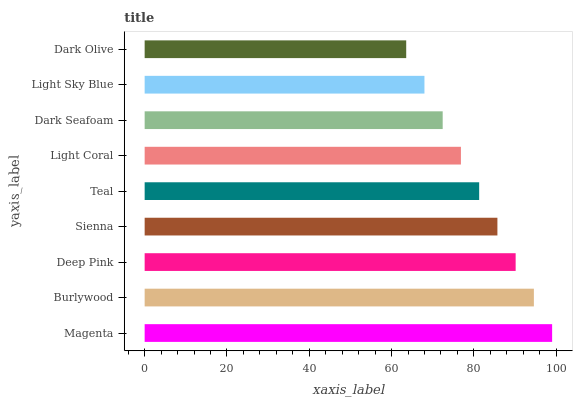Is Dark Olive the minimum?
Answer yes or no. Yes. Is Magenta the maximum?
Answer yes or no. Yes. Is Burlywood the minimum?
Answer yes or no. No. Is Burlywood the maximum?
Answer yes or no. No. Is Magenta greater than Burlywood?
Answer yes or no. Yes. Is Burlywood less than Magenta?
Answer yes or no. Yes. Is Burlywood greater than Magenta?
Answer yes or no. No. Is Magenta less than Burlywood?
Answer yes or no. No. Is Teal the high median?
Answer yes or no. Yes. Is Teal the low median?
Answer yes or no. Yes. Is Dark Olive the high median?
Answer yes or no. No. Is Sienna the low median?
Answer yes or no. No. 